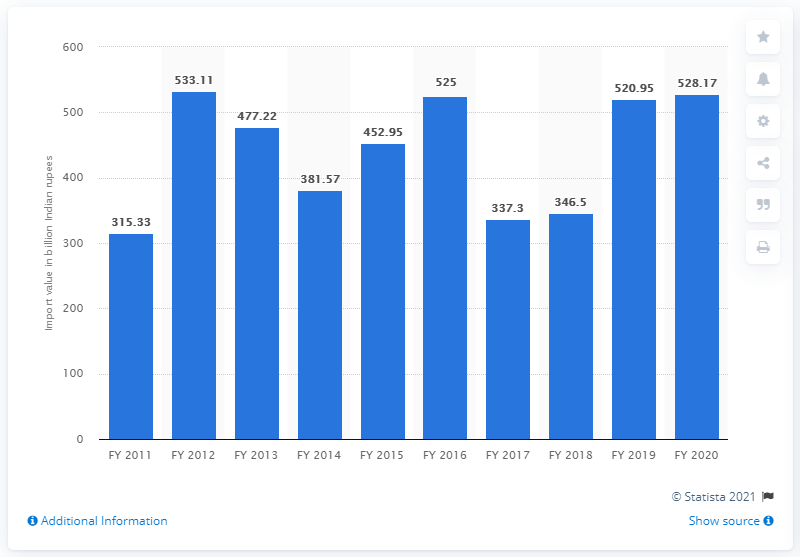Indicate a few pertinent items in this graphic. During the fiscal year 2020, India imported fertilizers worth approximately 528.17 million Indian rupees. 